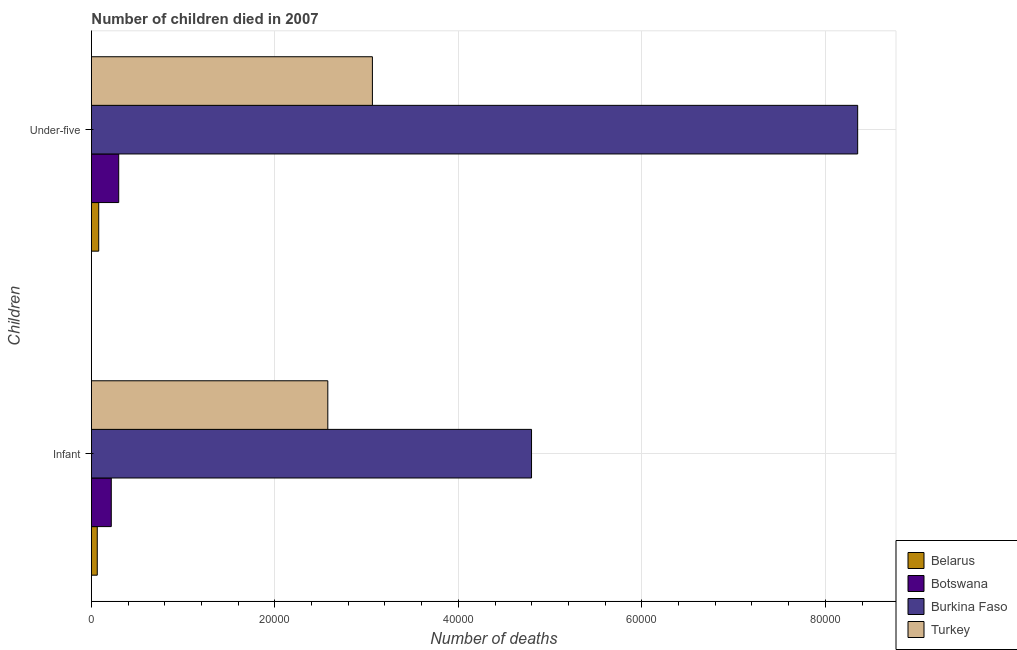How many groups of bars are there?
Your answer should be compact. 2. Are the number of bars per tick equal to the number of legend labels?
Offer a terse response. Yes. What is the label of the 1st group of bars from the top?
Keep it short and to the point. Under-five. What is the number of under-five deaths in Botswana?
Your answer should be very brief. 2976. Across all countries, what is the maximum number of infant deaths?
Offer a terse response. 4.80e+04. Across all countries, what is the minimum number of infant deaths?
Make the answer very short. 637. In which country was the number of under-five deaths maximum?
Give a very brief answer. Burkina Faso. In which country was the number of under-five deaths minimum?
Ensure brevity in your answer.  Belarus. What is the total number of infant deaths in the graph?
Provide a succinct answer. 7.65e+04. What is the difference between the number of infant deaths in Botswana and that in Belarus?
Your response must be concise. 1528. What is the difference between the number of under-five deaths in Burkina Faso and the number of infant deaths in Botswana?
Your response must be concise. 8.14e+04. What is the average number of under-five deaths per country?
Give a very brief answer. 2.95e+04. What is the difference between the number of under-five deaths and number of infant deaths in Turkey?
Your answer should be compact. 4862. In how many countries, is the number of infant deaths greater than 40000 ?
Offer a terse response. 1. What is the ratio of the number of under-five deaths in Burkina Faso to that in Turkey?
Ensure brevity in your answer.  2.73. In how many countries, is the number of infant deaths greater than the average number of infant deaths taken over all countries?
Ensure brevity in your answer.  2. What does the 4th bar from the top in Infant represents?
Your answer should be very brief. Belarus. What does the 1st bar from the bottom in Infant represents?
Offer a terse response. Belarus. Are the values on the major ticks of X-axis written in scientific E-notation?
Offer a terse response. No. Does the graph contain any zero values?
Ensure brevity in your answer.  No. How are the legend labels stacked?
Your answer should be very brief. Vertical. What is the title of the graph?
Your response must be concise. Number of children died in 2007. Does "Azerbaijan" appear as one of the legend labels in the graph?
Offer a very short reply. No. What is the label or title of the X-axis?
Provide a succinct answer. Number of deaths. What is the label or title of the Y-axis?
Make the answer very short. Children. What is the Number of deaths in Belarus in Infant?
Your answer should be compact. 637. What is the Number of deaths of Botswana in Infant?
Provide a short and direct response. 2165. What is the Number of deaths of Burkina Faso in Infant?
Offer a very short reply. 4.80e+04. What is the Number of deaths in Turkey in Infant?
Your response must be concise. 2.58e+04. What is the Number of deaths of Belarus in Under-five?
Your answer should be very brief. 795. What is the Number of deaths of Botswana in Under-five?
Your answer should be compact. 2976. What is the Number of deaths of Burkina Faso in Under-five?
Your response must be concise. 8.35e+04. What is the Number of deaths of Turkey in Under-five?
Ensure brevity in your answer.  3.06e+04. Across all Children, what is the maximum Number of deaths in Belarus?
Make the answer very short. 795. Across all Children, what is the maximum Number of deaths of Botswana?
Your answer should be very brief. 2976. Across all Children, what is the maximum Number of deaths in Burkina Faso?
Keep it short and to the point. 8.35e+04. Across all Children, what is the maximum Number of deaths of Turkey?
Your response must be concise. 3.06e+04. Across all Children, what is the minimum Number of deaths in Belarus?
Provide a short and direct response. 637. Across all Children, what is the minimum Number of deaths of Botswana?
Make the answer very short. 2165. Across all Children, what is the minimum Number of deaths of Burkina Faso?
Make the answer very short. 4.80e+04. Across all Children, what is the minimum Number of deaths in Turkey?
Offer a terse response. 2.58e+04. What is the total Number of deaths of Belarus in the graph?
Your answer should be compact. 1432. What is the total Number of deaths of Botswana in the graph?
Offer a very short reply. 5141. What is the total Number of deaths in Burkina Faso in the graph?
Keep it short and to the point. 1.31e+05. What is the total Number of deaths in Turkey in the graph?
Keep it short and to the point. 5.64e+04. What is the difference between the Number of deaths of Belarus in Infant and that in Under-five?
Make the answer very short. -158. What is the difference between the Number of deaths of Botswana in Infant and that in Under-five?
Keep it short and to the point. -811. What is the difference between the Number of deaths of Burkina Faso in Infant and that in Under-five?
Give a very brief answer. -3.56e+04. What is the difference between the Number of deaths in Turkey in Infant and that in Under-five?
Make the answer very short. -4862. What is the difference between the Number of deaths in Belarus in Infant and the Number of deaths in Botswana in Under-five?
Ensure brevity in your answer.  -2339. What is the difference between the Number of deaths in Belarus in Infant and the Number of deaths in Burkina Faso in Under-five?
Keep it short and to the point. -8.29e+04. What is the difference between the Number of deaths in Belarus in Infant and the Number of deaths in Turkey in Under-five?
Keep it short and to the point. -3.00e+04. What is the difference between the Number of deaths of Botswana in Infant and the Number of deaths of Burkina Faso in Under-five?
Give a very brief answer. -8.14e+04. What is the difference between the Number of deaths of Botswana in Infant and the Number of deaths of Turkey in Under-five?
Your response must be concise. -2.85e+04. What is the difference between the Number of deaths of Burkina Faso in Infant and the Number of deaths of Turkey in Under-five?
Offer a very short reply. 1.73e+04. What is the average Number of deaths of Belarus per Children?
Give a very brief answer. 716. What is the average Number of deaths in Botswana per Children?
Keep it short and to the point. 2570.5. What is the average Number of deaths in Burkina Faso per Children?
Keep it short and to the point. 6.57e+04. What is the average Number of deaths in Turkey per Children?
Keep it short and to the point. 2.82e+04. What is the difference between the Number of deaths of Belarus and Number of deaths of Botswana in Infant?
Provide a short and direct response. -1528. What is the difference between the Number of deaths in Belarus and Number of deaths in Burkina Faso in Infant?
Offer a terse response. -4.73e+04. What is the difference between the Number of deaths of Belarus and Number of deaths of Turkey in Infant?
Give a very brief answer. -2.51e+04. What is the difference between the Number of deaths in Botswana and Number of deaths in Burkina Faso in Infant?
Make the answer very short. -4.58e+04. What is the difference between the Number of deaths of Botswana and Number of deaths of Turkey in Infant?
Provide a succinct answer. -2.36e+04. What is the difference between the Number of deaths of Burkina Faso and Number of deaths of Turkey in Infant?
Offer a terse response. 2.22e+04. What is the difference between the Number of deaths of Belarus and Number of deaths of Botswana in Under-five?
Offer a terse response. -2181. What is the difference between the Number of deaths of Belarus and Number of deaths of Burkina Faso in Under-five?
Make the answer very short. -8.27e+04. What is the difference between the Number of deaths in Belarus and Number of deaths in Turkey in Under-five?
Ensure brevity in your answer.  -2.98e+04. What is the difference between the Number of deaths of Botswana and Number of deaths of Burkina Faso in Under-five?
Make the answer very short. -8.05e+04. What is the difference between the Number of deaths of Botswana and Number of deaths of Turkey in Under-five?
Keep it short and to the point. -2.77e+04. What is the difference between the Number of deaths of Burkina Faso and Number of deaths of Turkey in Under-five?
Provide a succinct answer. 5.29e+04. What is the ratio of the Number of deaths of Belarus in Infant to that in Under-five?
Give a very brief answer. 0.8. What is the ratio of the Number of deaths of Botswana in Infant to that in Under-five?
Offer a terse response. 0.73. What is the ratio of the Number of deaths of Burkina Faso in Infant to that in Under-five?
Give a very brief answer. 0.57. What is the ratio of the Number of deaths in Turkey in Infant to that in Under-five?
Provide a succinct answer. 0.84. What is the difference between the highest and the second highest Number of deaths in Belarus?
Provide a short and direct response. 158. What is the difference between the highest and the second highest Number of deaths in Botswana?
Give a very brief answer. 811. What is the difference between the highest and the second highest Number of deaths of Burkina Faso?
Ensure brevity in your answer.  3.56e+04. What is the difference between the highest and the second highest Number of deaths in Turkey?
Your answer should be compact. 4862. What is the difference between the highest and the lowest Number of deaths in Belarus?
Provide a short and direct response. 158. What is the difference between the highest and the lowest Number of deaths of Botswana?
Make the answer very short. 811. What is the difference between the highest and the lowest Number of deaths in Burkina Faso?
Give a very brief answer. 3.56e+04. What is the difference between the highest and the lowest Number of deaths in Turkey?
Ensure brevity in your answer.  4862. 